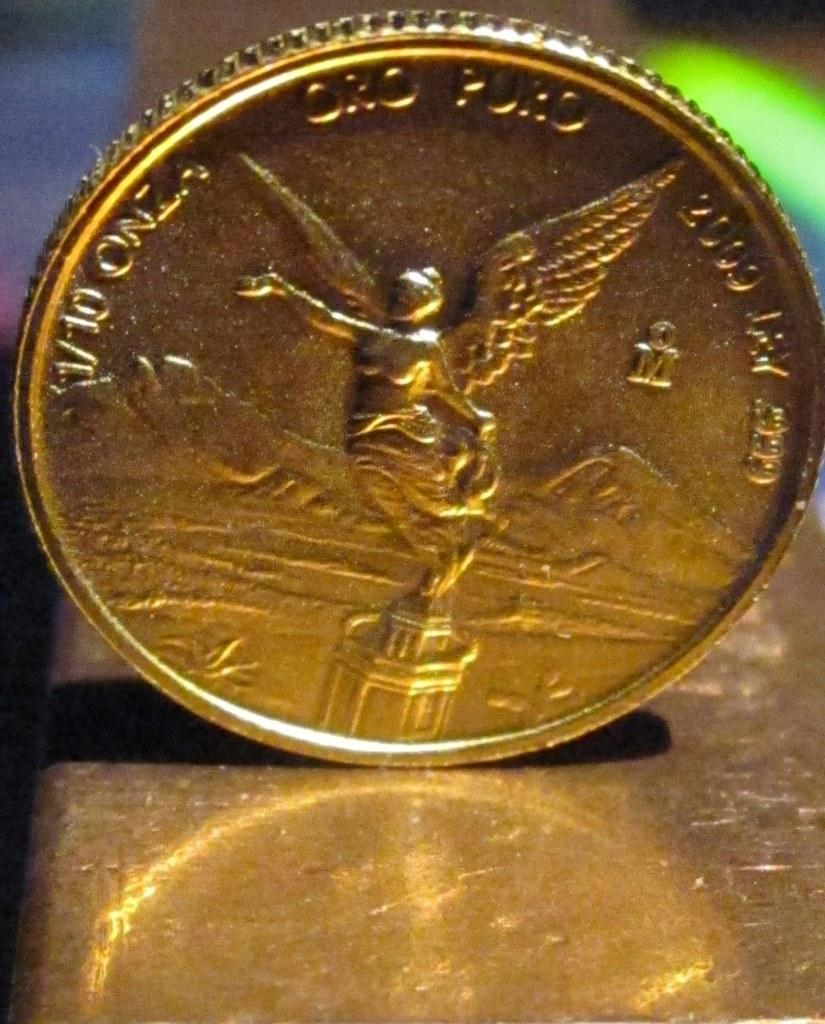<image>
Describe the image concisely. A cone with the numbers 1/10 and a woman with wings spread wide. 